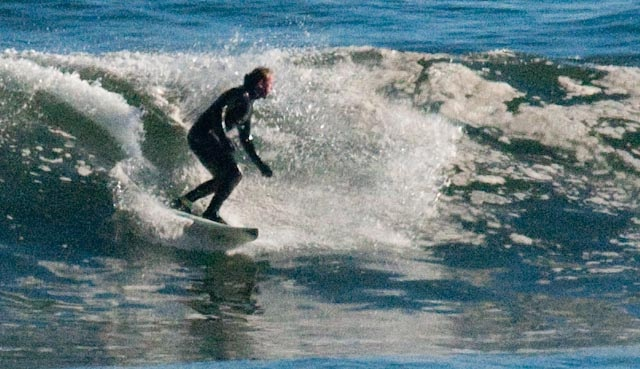Describe the objects in this image and their specific colors. I can see people in blue, black, gray, darkgray, and purple tones and surfboard in blue, gray, darkgray, lightgray, and purple tones in this image. 